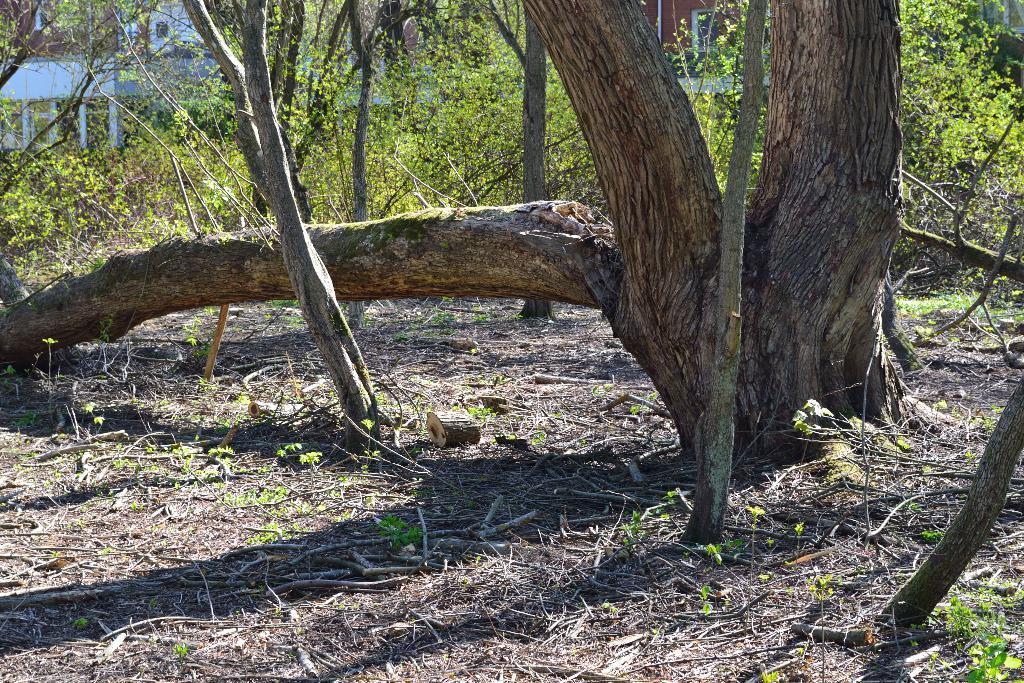In one or two sentences, can you explain what this image depicts? In the picture I can see the trunk of a tree on the right side. I can see the broken trunk of a tree on the ground. In the background, I can see the buildings and trees. 